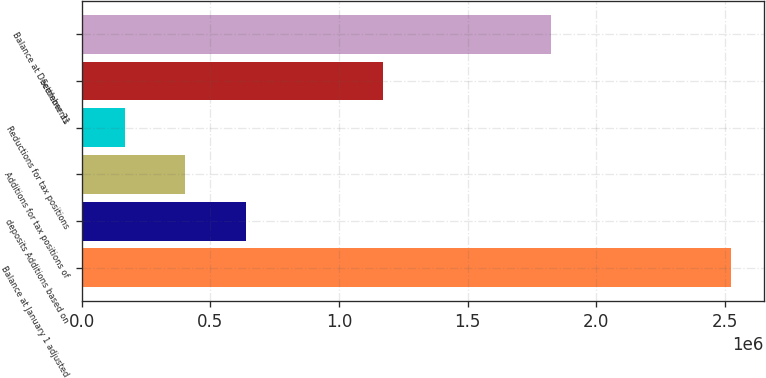Convert chart to OTSL. <chart><loc_0><loc_0><loc_500><loc_500><bar_chart><fcel>Balance at January 1 adjusted<fcel>deposits Additions based on<fcel>Additions for tax positions of<fcel>Reductions for tax positions<fcel>Settlements<fcel>Balance at December 31<nl><fcel>2.52379e+06<fcel>638080<fcel>402365<fcel>166651<fcel>1.16932e+06<fcel>1.82545e+06<nl></chart> 